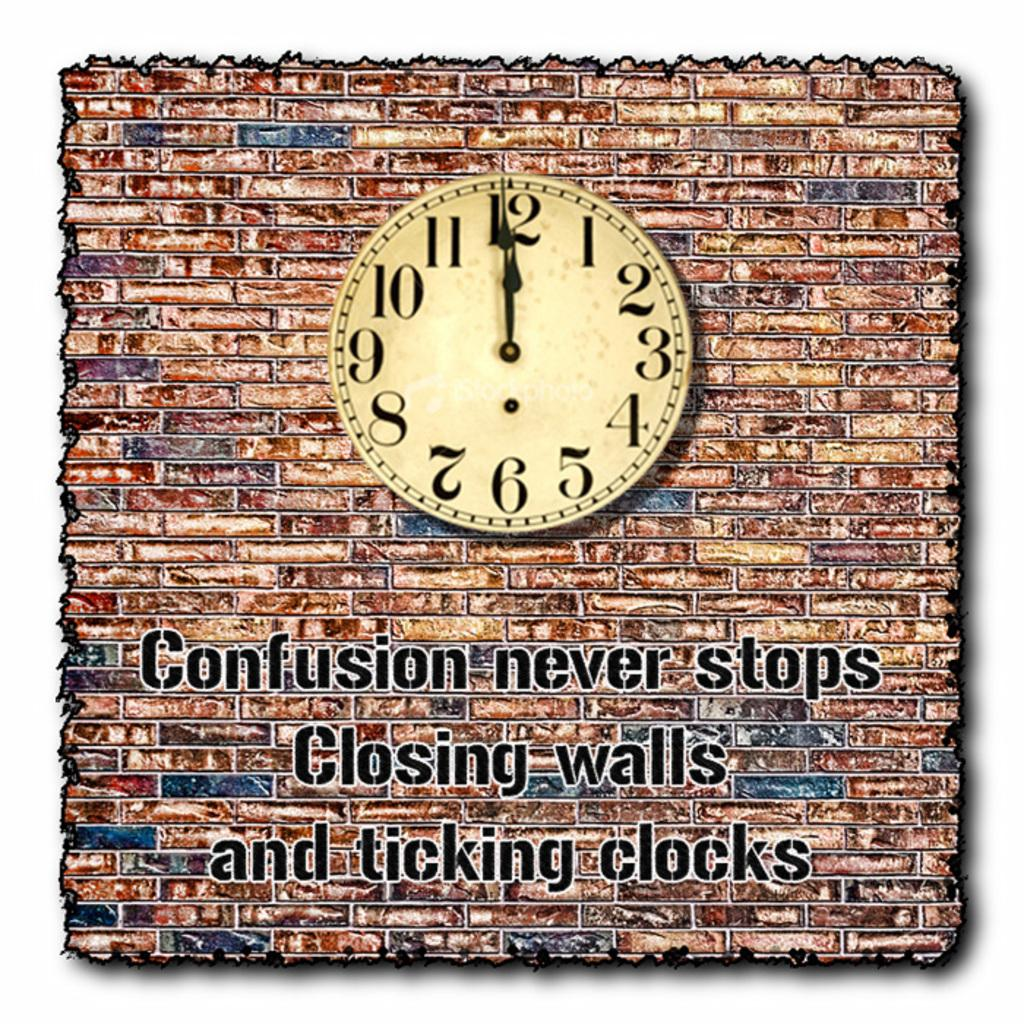<image>
Render a clear and concise summary of the photo. A poster showing a clock on a brick wall with the legend "confusion never stops / closing walls / and ticking clocks". 